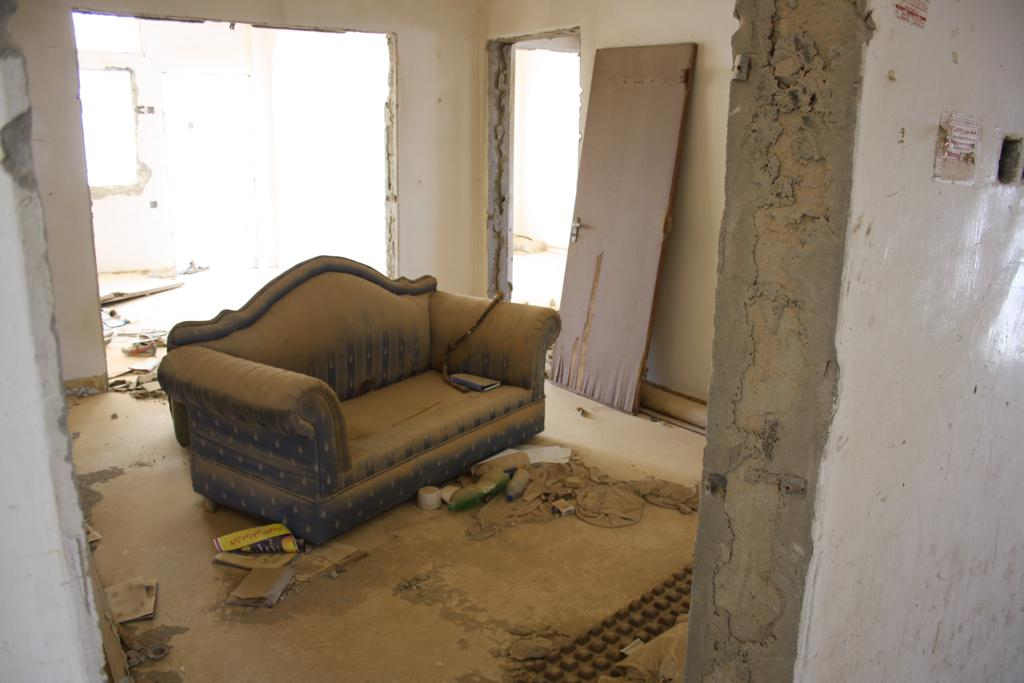What type of furniture is in the image? There is a sofa in the image. Where is the sofa located? The sofa is on the floor. What other objects can be seen in the image? There is a door and a wall in the image. What brand of toothpaste is on the wall in the image? There is no toothpaste present in the image; it only features a sofa, a door, and a wall. 